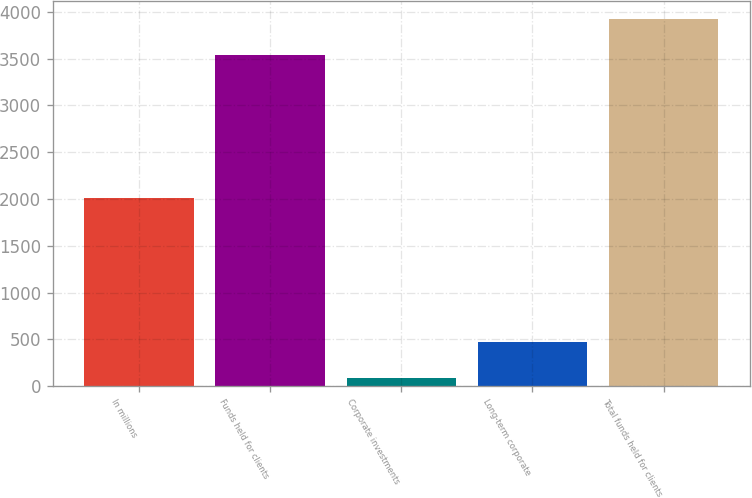Convert chart. <chart><loc_0><loc_0><loc_500><loc_500><bar_chart><fcel>In millions<fcel>Funds held for clients<fcel>Corporate investments<fcel>Long-term corporate<fcel>Total funds held for clients<nl><fcel>2010<fcel>3541<fcel>82.5<fcel>465.61<fcel>3924.11<nl></chart> 